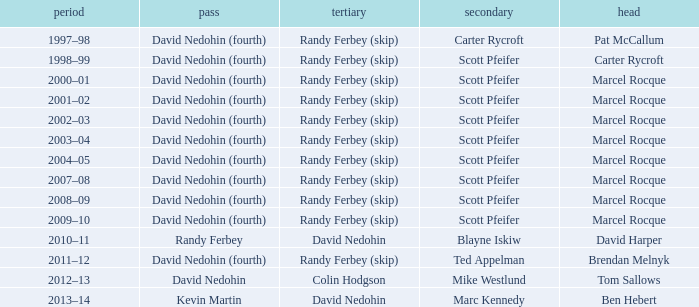Which Second has a Third of david nedohin, and a Lead of ben hebert? Marc Kennedy. 